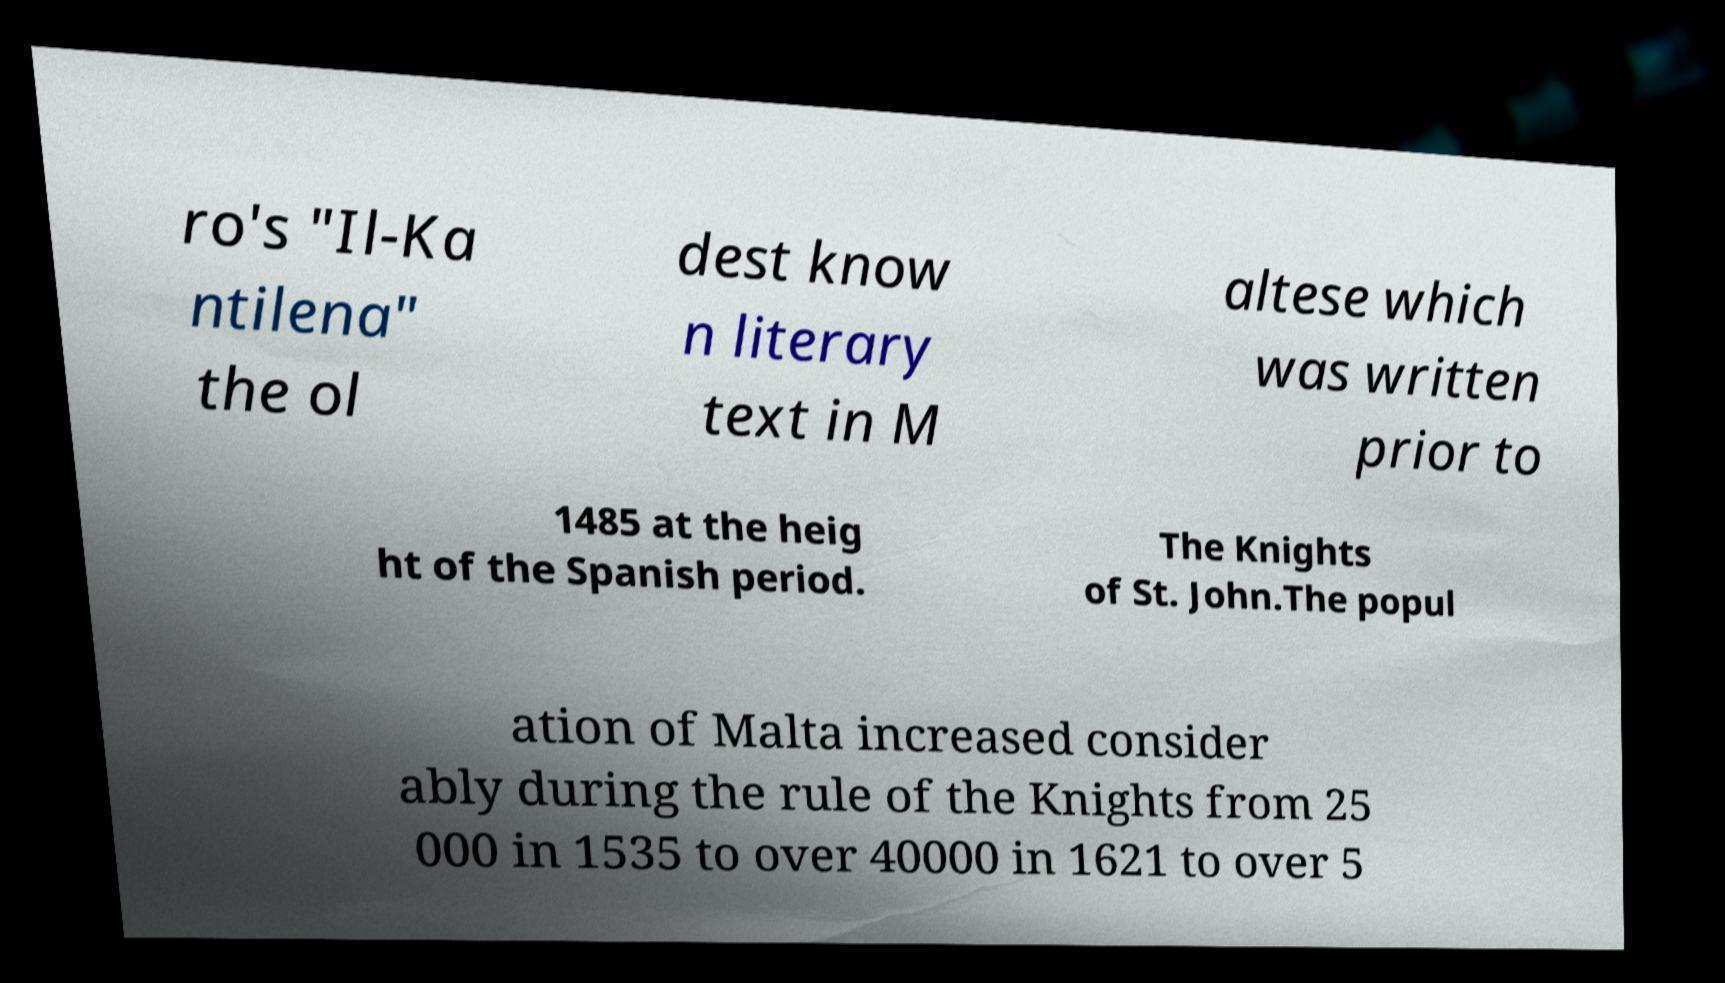Please identify and transcribe the text found in this image. ro's "Il-Ka ntilena" the ol dest know n literary text in M altese which was written prior to 1485 at the heig ht of the Spanish period. The Knights of St. John.The popul ation of Malta increased consider ably during the rule of the Knights from 25 000 in 1535 to over 40000 in 1621 to over 5 